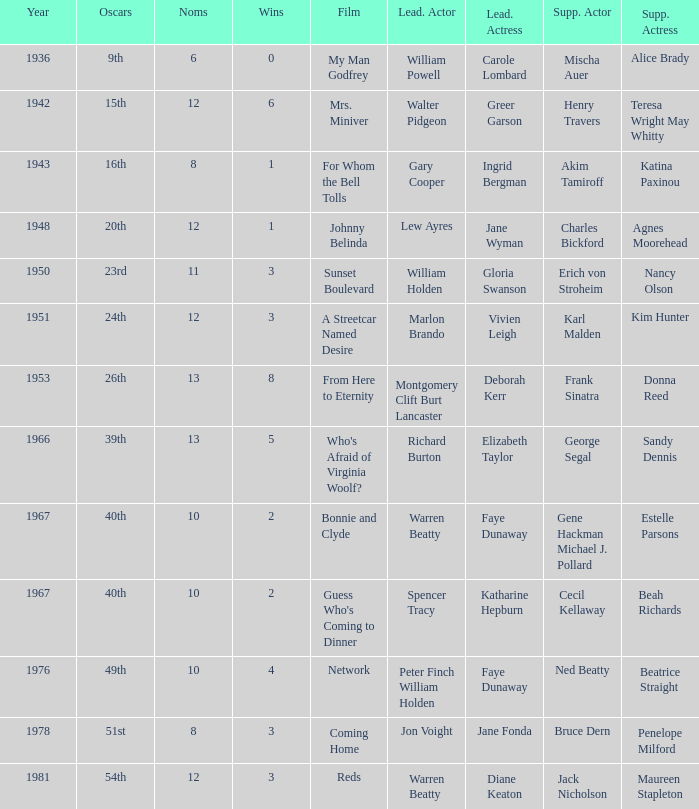Who was the leading actress in a film with Warren Beatty as the leading actor and also at the 40th Oscars? Faye Dunaway. 